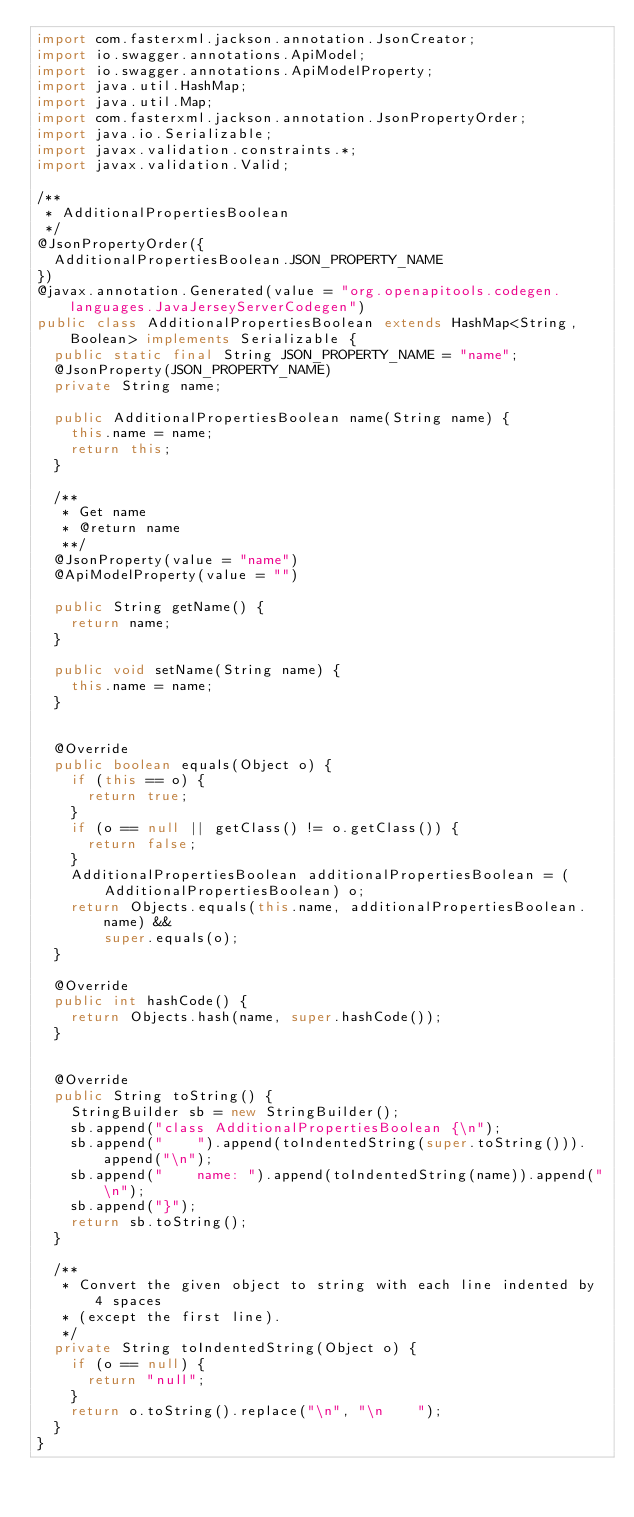Convert code to text. <code><loc_0><loc_0><loc_500><loc_500><_Java_>import com.fasterxml.jackson.annotation.JsonCreator;
import io.swagger.annotations.ApiModel;
import io.swagger.annotations.ApiModelProperty;
import java.util.HashMap;
import java.util.Map;
import com.fasterxml.jackson.annotation.JsonPropertyOrder;
import java.io.Serializable;
import javax.validation.constraints.*;
import javax.validation.Valid;

/**
 * AdditionalPropertiesBoolean
 */
@JsonPropertyOrder({
  AdditionalPropertiesBoolean.JSON_PROPERTY_NAME
})
@javax.annotation.Generated(value = "org.openapitools.codegen.languages.JavaJerseyServerCodegen")
public class AdditionalPropertiesBoolean extends HashMap<String, Boolean> implements Serializable {
  public static final String JSON_PROPERTY_NAME = "name";
  @JsonProperty(JSON_PROPERTY_NAME)
  private String name;

  public AdditionalPropertiesBoolean name(String name) {
    this.name = name;
    return this;
  }

  /**
   * Get name
   * @return name
   **/
  @JsonProperty(value = "name")
  @ApiModelProperty(value = "")
  
  public String getName() {
    return name;
  }

  public void setName(String name) {
    this.name = name;
  }


  @Override
  public boolean equals(Object o) {
    if (this == o) {
      return true;
    }
    if (o == null || getClass() != o.getClass()) {
      return false;
    }
    AdditionalPropertiesBoolean additionalPropertiesBoolean = (AdditionalPropertiesBoolean) o;
    return Objects.equals(this.name, additionalPropertiesBoolean.name) &&
        super.equals(o);
  }

  @Override
  public int hashCode() {
    return Objects.hash(name, super.hashCode());
  }


  @Override
  public String toString() {
    StringBuilder sb = new StringBuilder();
    sb.append("class AdditionalPropertiesBoolean {\n");
    sb.append("    ").append(toIndentedString(super.toString())).append("\n");
    sb.append("    name: ").append(toIndentedString(name)).append("\n");
    sb.append("}");
    return sb.toString();
  }

  /**
   * Convert the given object to string with each line indented by 4 spaces
   * (except the first line).
   */
  private String toIndentedString(Object o) {
    if (o == null) {
      return "null";
    }
    return o.toString().replace("\n", "\n    ");
  }
}

</code> 